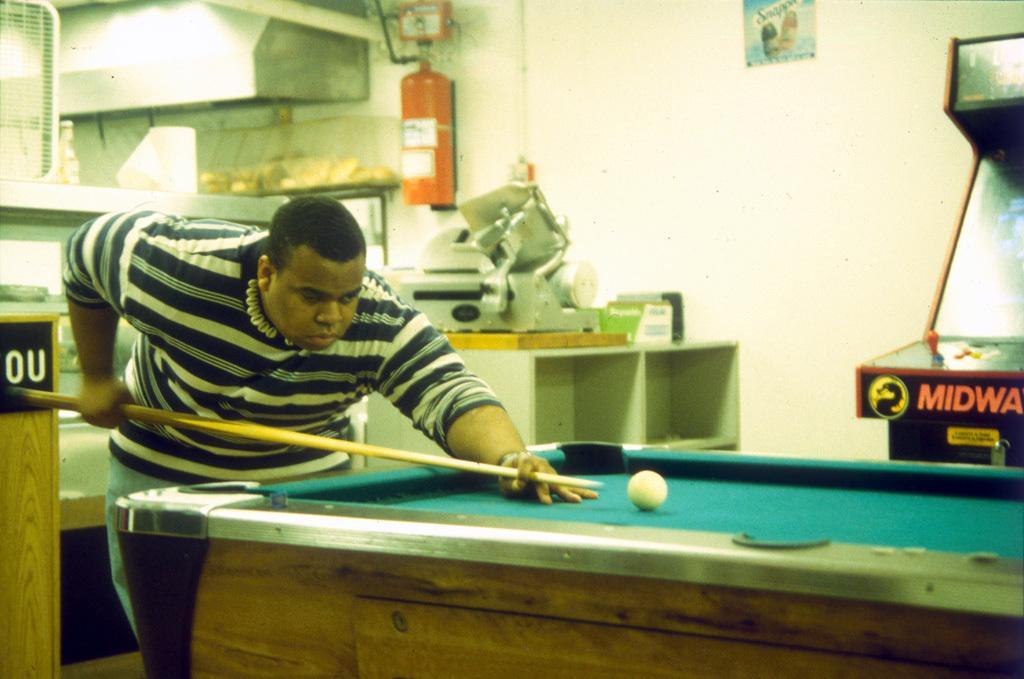How would you summarize this image in a sentence or two? In this image, I can see a person standing and holding a cue stick. I can see a billiard table with a billiard ball. On the right side of the image, there is a gaming machine. At the top of the image, I can see a poster attached to the wall. Behind the person, I can see a machine, the racks, fire extinguisher, chimney and few other objects. On the left side of the image, I can see a wooden object. 